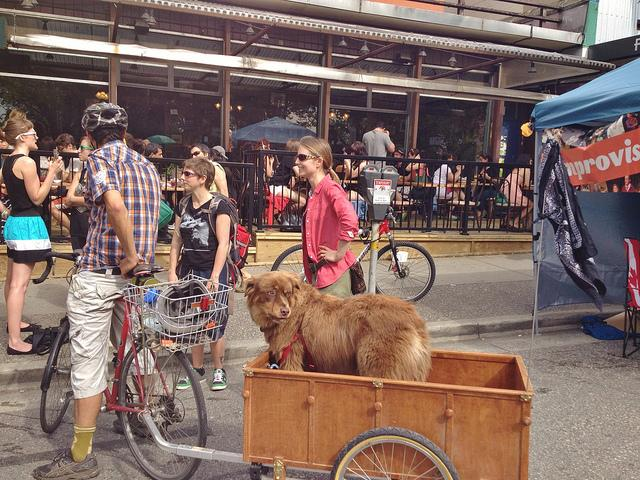What is the dog riding in? Please explain your reasoning. wagon. It is a small cart that is towed behind something 